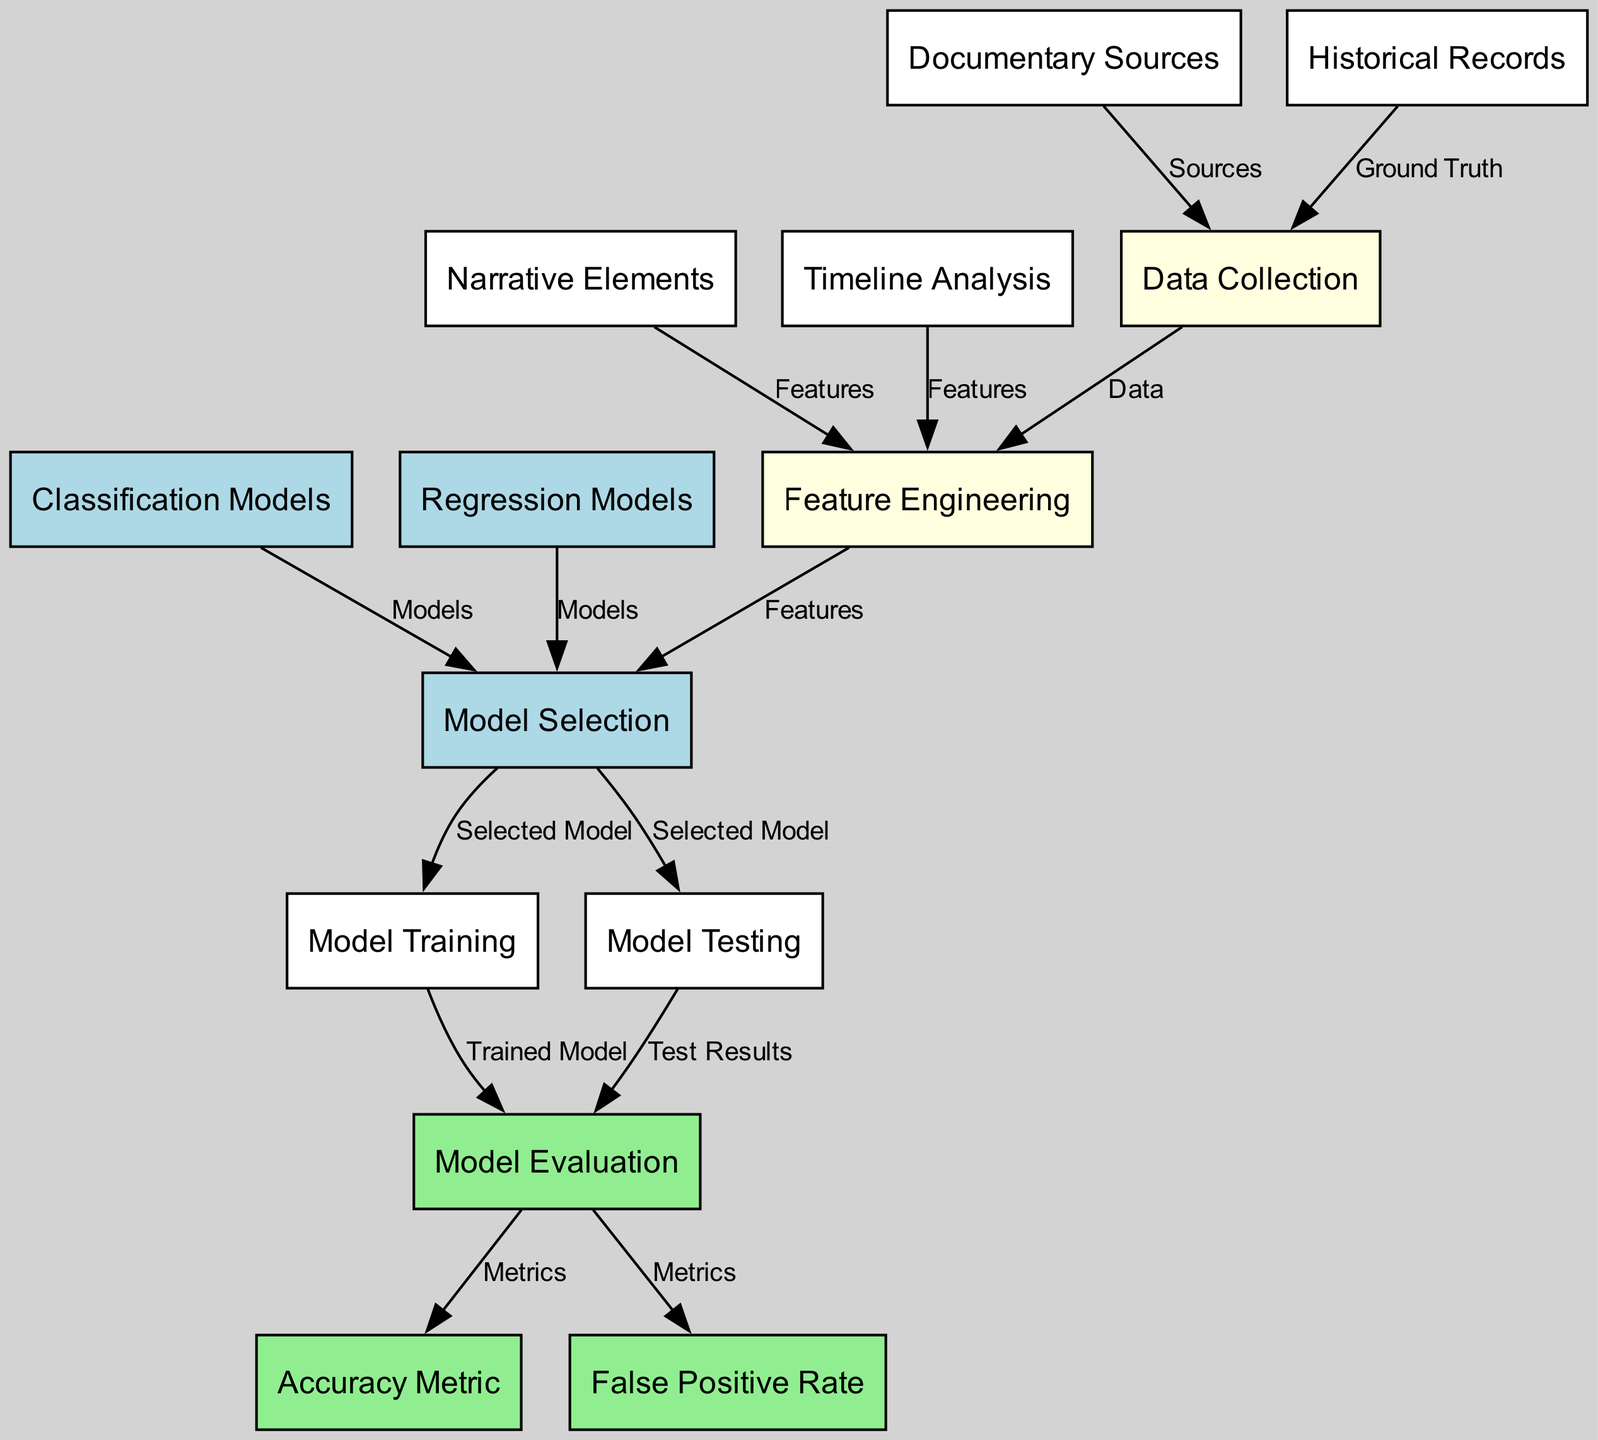What's the total number of nodes in the diagram? By counting the unique nodes represented in the diagram, we determine that there are 13 nodes listed.
Answer: 13 What type of models are chosen in the model selection phase? By observing the connections, we see that both classification models and regression models are involved in the model selection process.
Answer: Classification and regression models What is the relationship between data collection and historical records? The diagram indicates that the historical records provide the ground truth for data collection, illustrating a direct connection between these two nodes.
Answer: Ground truth Which node receives input from feature engineering? The model selection node is recipient of features derived from the feature engineering process, highlighting its role in the selection stage.
Answer: Model selection How many metrics are associated with the evaluation stage? The evaluation node connects to two metrics: accuracy metric and false positive rate, thus indicating there are two associated metrics.
Answer: Two What stage follows model testing according to the diagram? The testing phase directly leads to the evaluation stage, making evaluation the subsequent step after model testing.
Answer: Evaluation Which node represents the various sources of data? The node labeled "Documentary Sources" specifically denotes the origins of data used in this modeling process.
Answer: Documentary Sources What needs to happen before model training can commence? The selected model must come from the model selection phase before proceeding to training, as indicated by the directed flow in the diagram.
Answer: Model selection What are the two types of features identified in feature engineering? The feature engineering node incorporates both narrative elements and timeline analysis as its inputs, marking them as the identified features.
Answer: Narrative elements and timeline analysis 